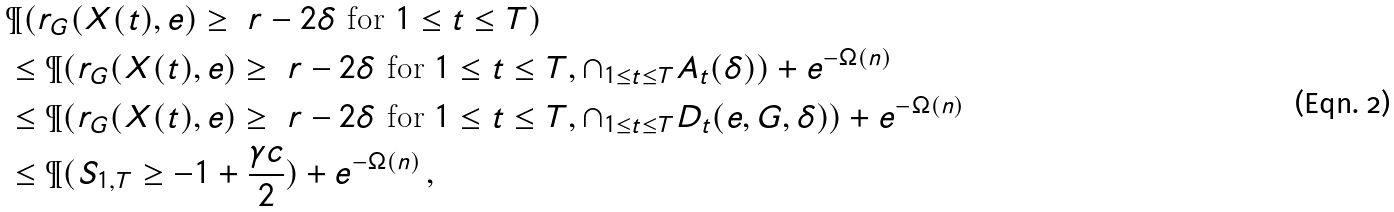<formula> <loc_0><loc_0><loc_500><loc_500>& \P ( r _ { G } ( X ( t ) , e ) \geq \ r - 2 \delta \text { for } 1 \leq t \leq T ) \\ & \leq \P ( r _ { G } ( X ( t ) , e ) \geq \ r - 2 \delta \text { for } 1 \leq t \leq T , \cap _ { 1 \leq t \leq T } A _ { t } ( \delta ) ) + e ^ { - \Omega ( n ) } \\ & \leq \P ( r _ { G } ( X ( t ) , e ) \geq \ r - 2 \delta \text { for } 1 \leq t \leq T , \cap _ { 1 \leq t \leq T } D _ { t } ( e , G , \delta ) ) + e ^ { - \Omega ( n ) } \\ & \leq \P ( S _ { 1 , T } \geq - 1 + \frac { \gamma c } { 2 } ) + e ^ { - \Omega ( n ) } \, ,</formula> 